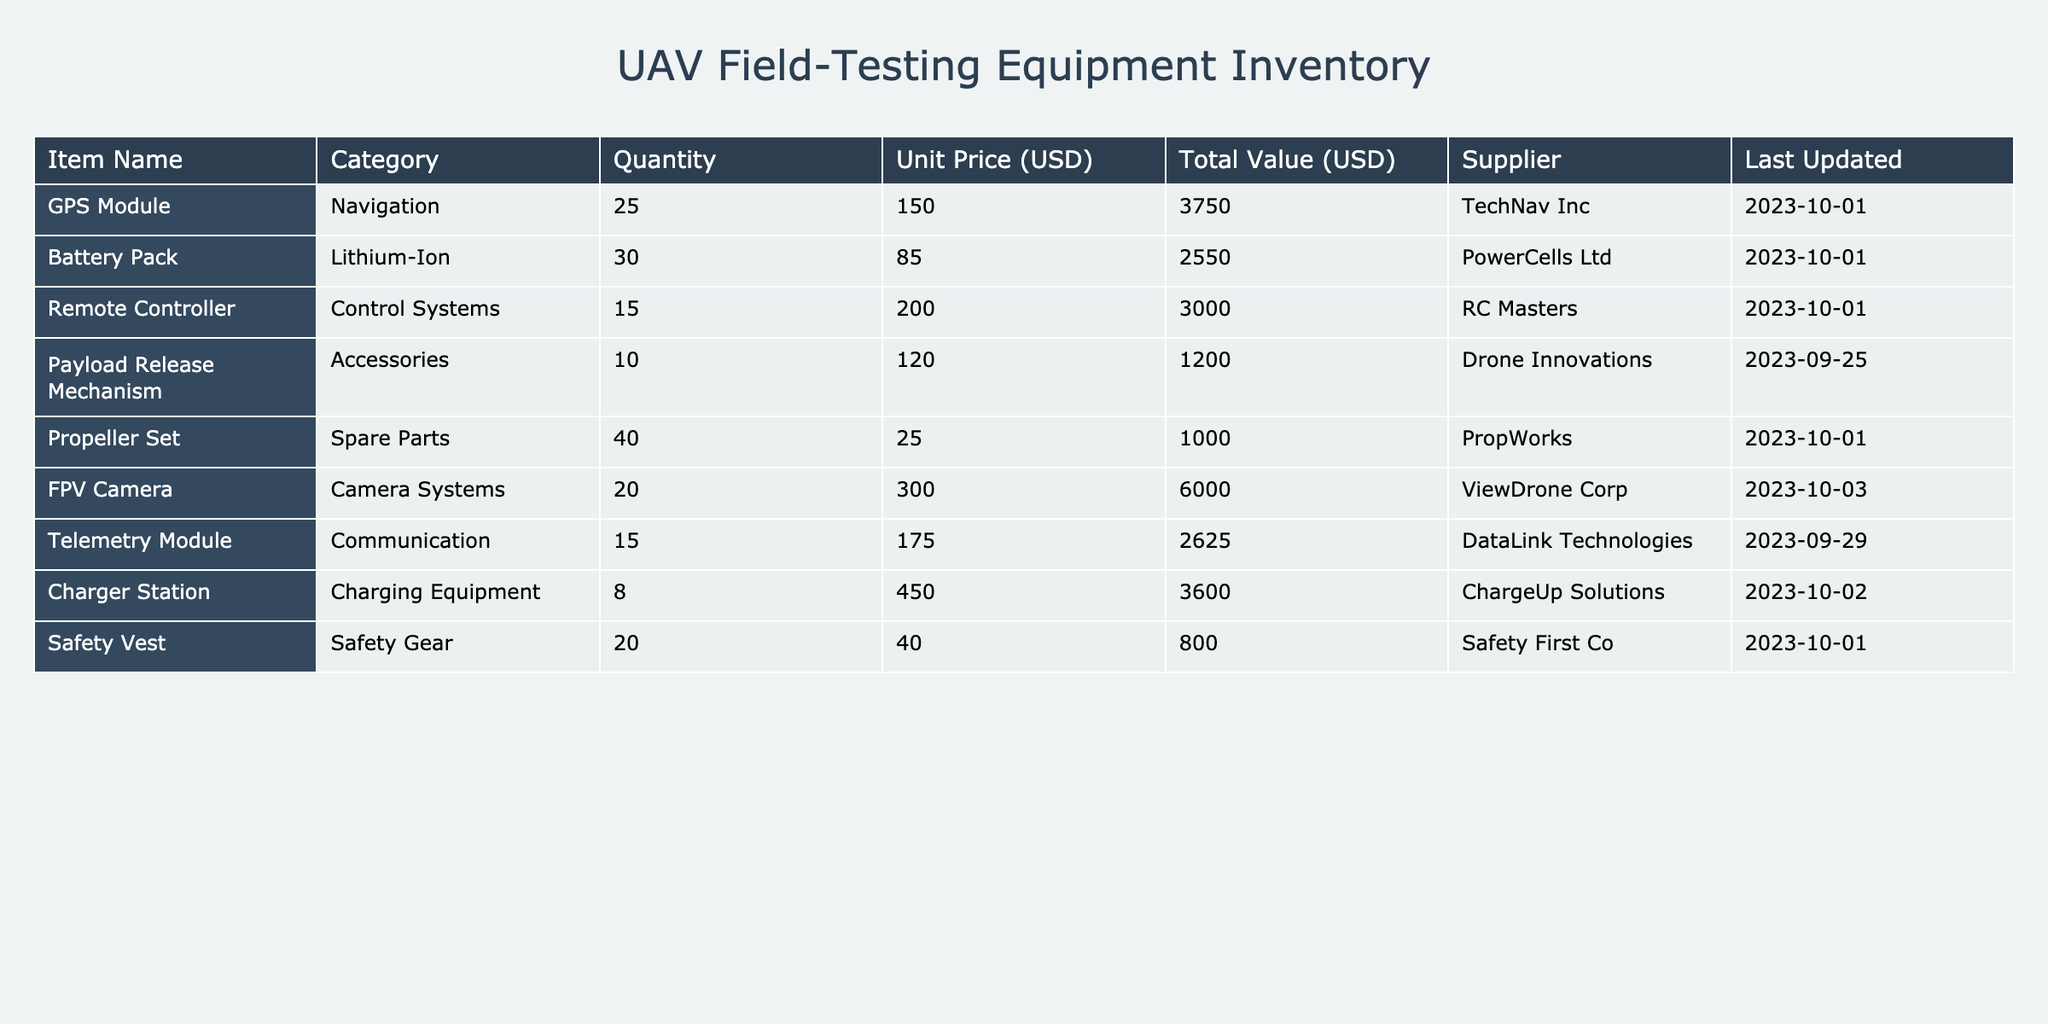What is the total quantity of batteries available? The table indicates that there are 30 Battery Packs listed under the Quantity column. Therefore, the total quantity of batteries available is 30.
Answer: 30 Which item has the highest total value? By reviewing the Total Value column, the FPV Camera has the highest total value of 6000 USD compared to the other items listed.
Answer: FPV Camera Are there more safety vests than remote controllers? There are 20 Safety Vests and 15 Remote Controllers in the table. Since 20 is greater than 15, the statement is true.
Answer: Yes What is the combined total value of GPS Modules and Telemetry Modules? The total value of GPS Modules is 3750 USD and for Telemetry Modules, it is 2625 USD. Adding these two values together gives 3750 + 2625 = 6375 USD for the combined total value.
Answer: 6375 How many more propeller sets are there than payload release mechanisms? The table shows that there are 40 Propeller Sets and 10 Payload Release Mechanisms. To find the difference, subtract 10 from 40, which results in 30. Therefore, there are 30 more propeller sets.
Answer: 30 Is the last update date for the Charger Station later than for the Battery Pack? The last updated date for the Charger Station is 2023-10-02 and for the Battery Pack, it is 2023-10-01. Since 2023-10-02 is later than 2023-10-01, the statement is true.
Answer: Yes What is the average unit price of all accessories? There is one accessory listed, the Payload Release Mechanism, with a unit price of 120 USD. Since there is only one item, the average unit price is simply 120 USD divided by 1, which equals 120.
Answer: 120 What is the total quantity of items listed in the inventory? Adding up the quantity of each item: 25 (GPS Module) + 30 (Battery Pack) + 15 (Remote Controller) + 10 (Payload Release Mechanism) + 40 (Propeller Set) + 20 (FPV Camera) + 15 (Telemetry Module) + 8 (Charger Station) + 20 (Safety Vest) gives a total of 283 items listed in the inventory.
Answer: 283 Is the quantity of telemetry modules greater than that of the GPS modules? The table shows there are 15 Telemetry Modules and 25 GPS Modules. Since 15 is less than 25, the statement is false.
Answer: No 